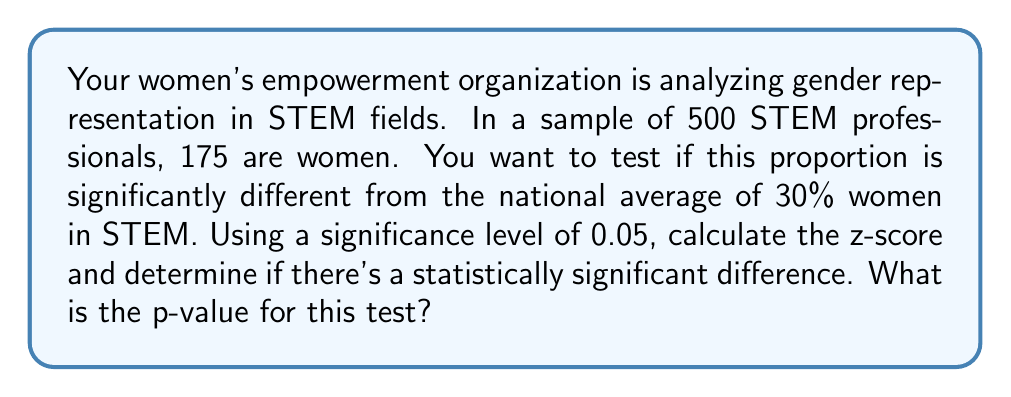Help me with this question. To solve this problem, we'll follow these steps:

1) First, let's define our hypotheses:
   $H_0: p = 0.30$ (null hypothesis)
   $H_a: p \neq 0.30$ (alternative hypothesis)

2) Calculate the sample proportion:
   $\hat{p} = \frac{175}{500} = 0.35$

3) Calculate the standard error:
   $SE = \sqrt{\frac{p_0(1-p_0)}{n}} = \sqrt{\frac{0.30(1-0.30)}{500}} = 0.0205$

4) Calculate the z-score:
   $z = \frac{\hat{p} - p_0}{SE} = \frac{0.35 - 0.30}{0.0205} = 2.44$

5) Find the p-value:
   For a two-tailed test, p-value = $2 * P(Z > |z|)$
   Using a standard normal distribution table or calculator:
   $P(Z > 2.44) = 0.0073$
   p-value = $2 * 0.0073 = 0.0146$

6) Compare p-value to significance level:
   0.0146 < 0.05, so we reject the null hypothesis.

Therefore, there is a statistically significant difference in the proportion of women in this sample compared to the national average.
Answer: p-value = 0.0146 